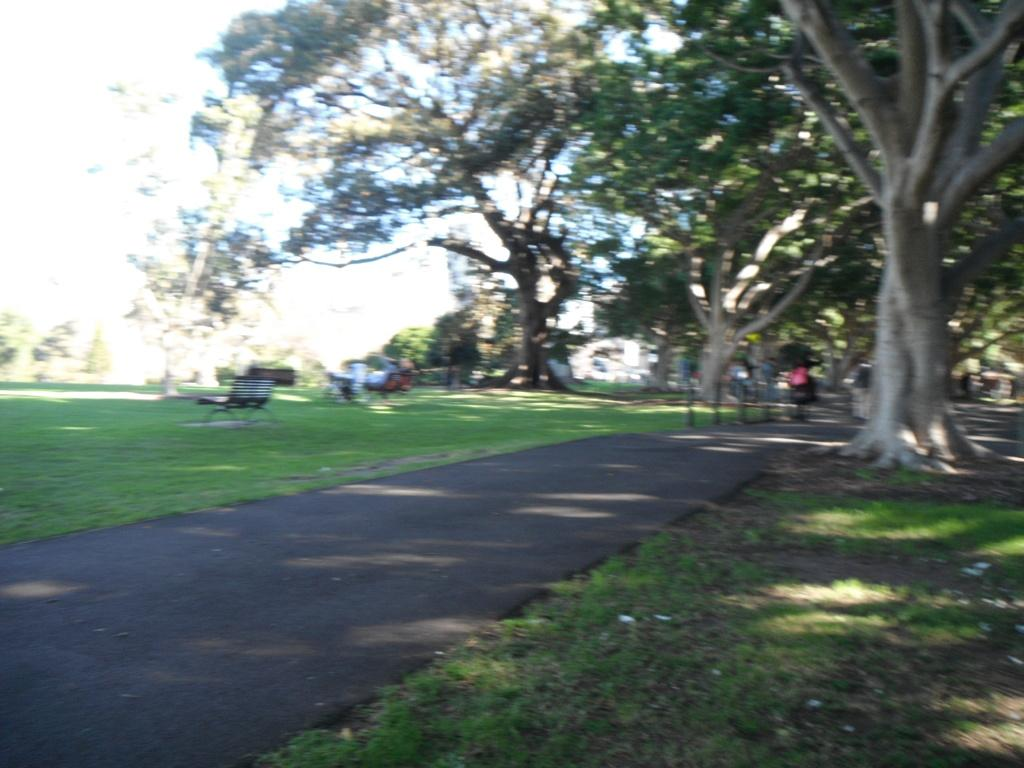What type of vegetation is at the bottom of the image? There is grass at the bottom of the image. What other natural elements can be seen in the image? There are trees in the image. What type of seating is present in the image? There is a bench in the image. What is visible at the top left of the image? The sky is visible at the top left of the image. How many eyes can be seen on the trees in the image? There are no eyes present on the trees in the image; they are natural elements and do not have eyes. What type of wealth is depicted in the image? There is no depiction of wealth in the image; it features grass, trees, a bench, and the sky. 